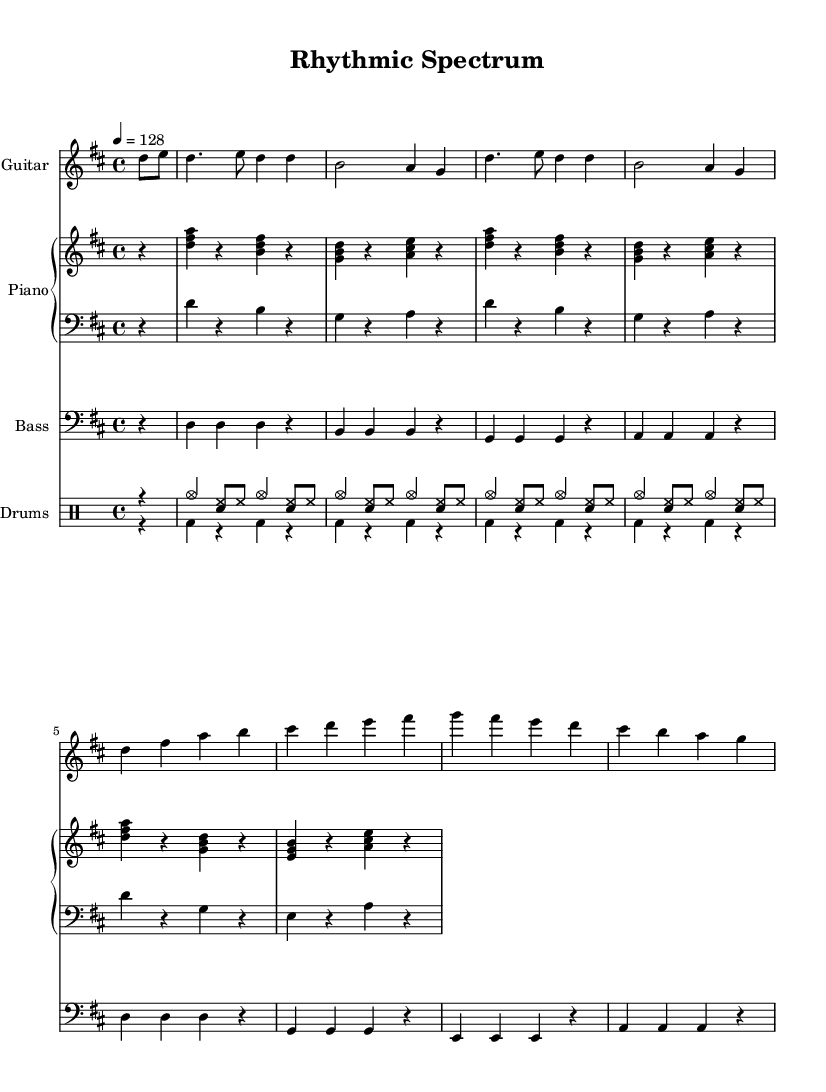what is the key signature of this music? The key signature is indicated by the sharp symbols in the staff, showing D major has two sharps (F# and C#).
Answer: D major what is the time signature of this music? The time signature is displayed at the beginning of the score, which reads "4/4," meaning there are four beats in each measure.
Answer: 4/4 what is the tempo marking of the piece? The tempo marking indicates the speed of the piece, showing a quarter note gets 128 beats per minute.
Answer: 128 what is the last note in the guitar part? The last note of the guitar part is identifiable as the lower "g" note located at the end of the last bar.
Answer: g which instrument has the highest range in this score? By examining the ranges of each instrument, the piano's right hand contains higher notes compared to the others, making it the instrument with the highest range.
Answer: Piano how many measures are in the total score? Counting the measures in each part leads to a total of 16 measures, which includes the rhythms and melodies across the instruments.
Answer: 16 how does the rhythm change between the drums up and drums down sections? The 'drums up' part features a persistent pattern of cymbals and hi-hat with snare, while 'drums down' focuses only on bass drum hits without any extra embellishments, demonstrating a contrast in complexity.
Answer: Contrast 